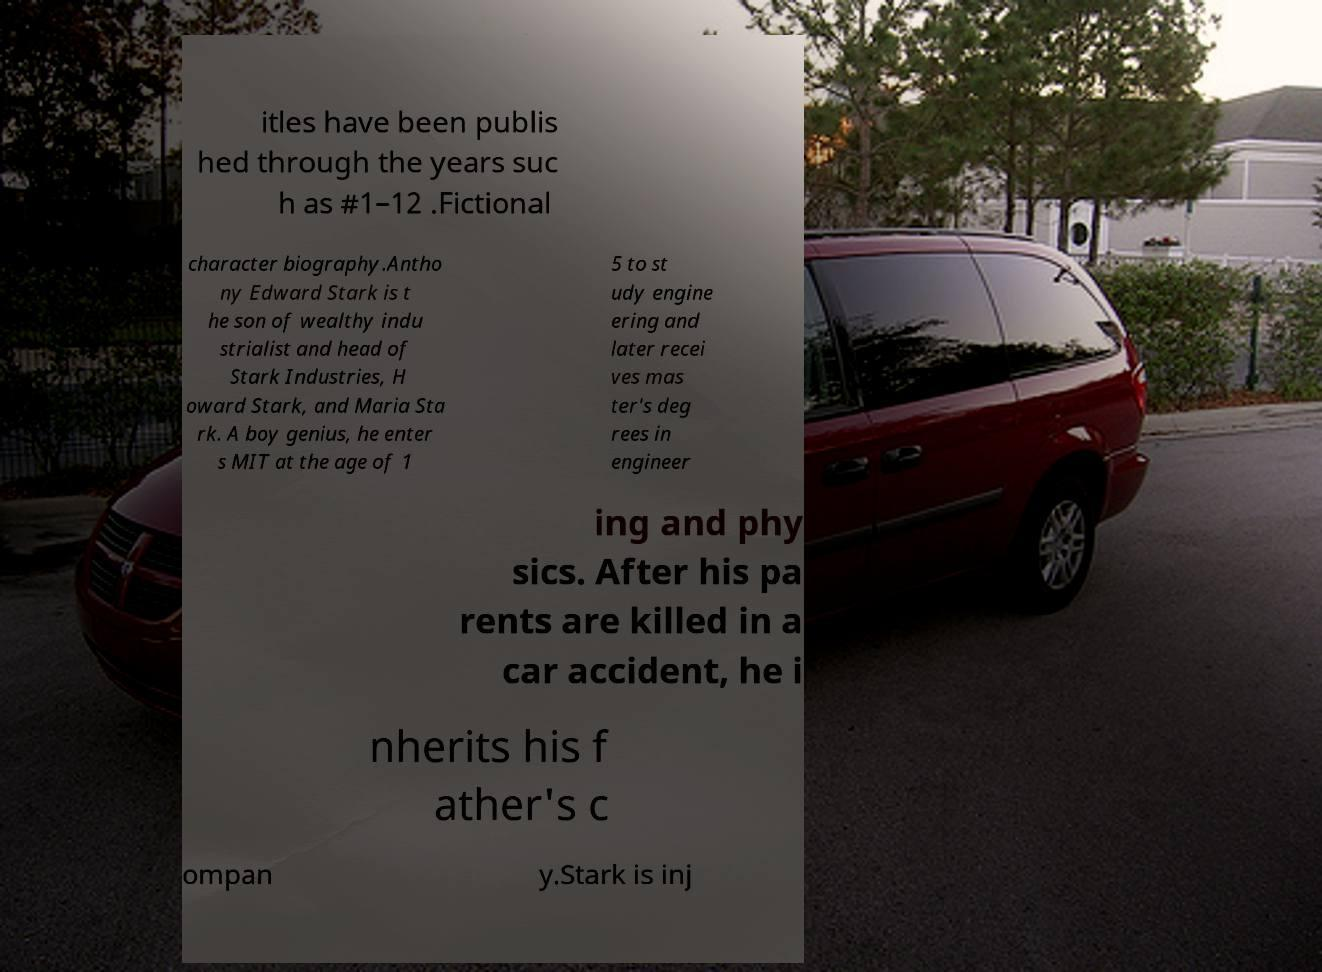Please identify and transcribe the text found in this image. itles have been publis hed through the years suc h as #1–12 .Fictional character biography.Antho ny Edward Stark is t he son of wealthy indu strialist and head of Stark Industries, H oward Stark, and Maria Sta rk. A boy genius, he enter s MIT at the age of 1 5 to st udy engine ering and later recei ves mas ter's deg rees in engineer ing and phy sics. After his pa rents are killed in a car accident, he i nherits his f ather's c ompan y.Stark is inj 